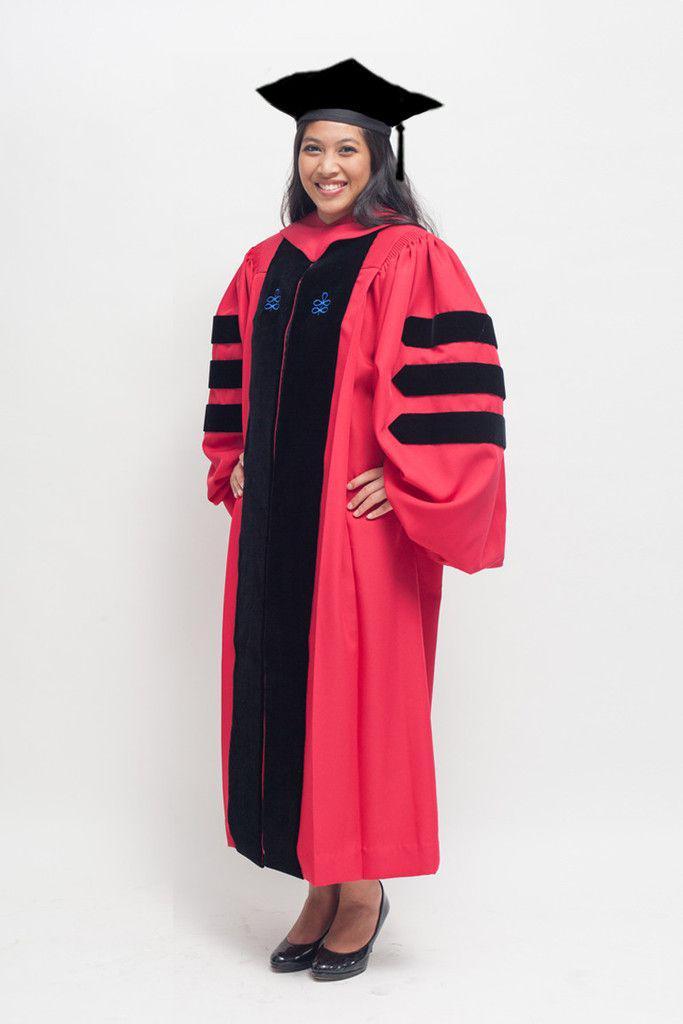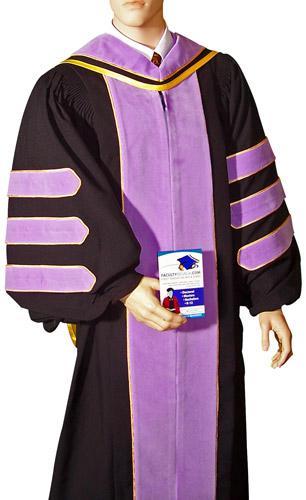The first image is the image on the left, the second image is the image on the right. Examine the images to the left and right. Is the description "There is at least one unworn academic gown facing slightly to the right." accurate? Answer yes or no. No. The first image is the image on the left, the second image is the image on the right. For the images displayed, is the sentence "One image shows a purple and black gown angled facing slightly rightward." factually correct? Answer yes or no. Yes. 